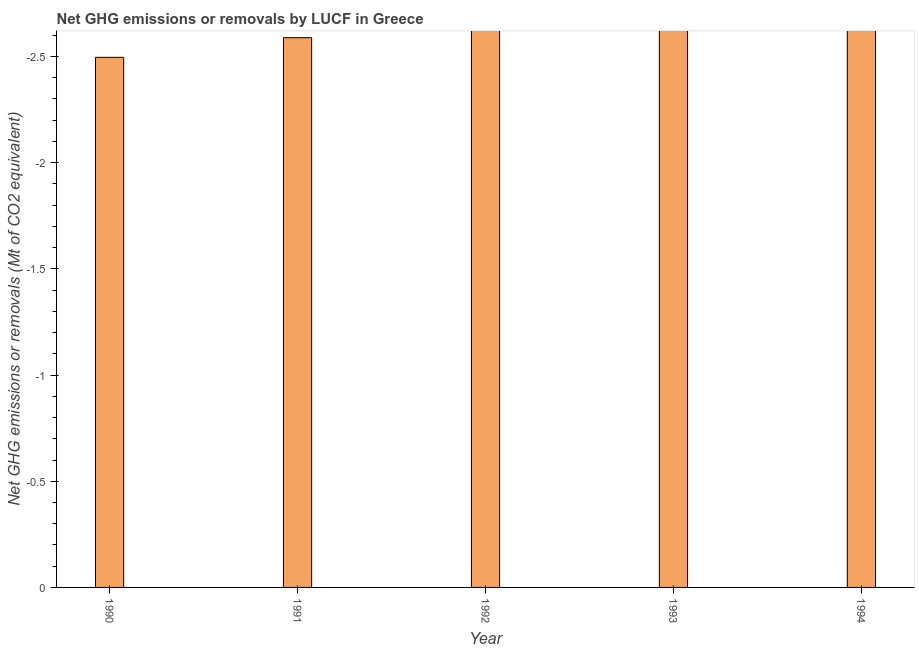What is the title of the graph?
Offer a very short reply. Net GHG emissions or removals by LUCF in Greece. What is the label or title of the Y-axis?
Ensure brevity in your answer.  Net GHG emissions or removals (Mt of CO2 equivalent). Across all years, what is the minimum ghg net emissions or removals?
Ensure brevity in your answer.  0. What is the sum of the ghg net emissions or removals?
Your answer should be very brief. 0. What is the median ghg net emissions or removals?
Provide a short and direct response. 0. In how many years, is the ghg net emissions or removals greater than the average ghg net emissions or removals taken over all years?
Your answer should be compact. 0. How many bars are there?
Offer a terse response. 0. How many years are there in the graph?
Offer a very short reply. 5. What is the Net GHG emissions or removals (Mt of CO2 equivalent) in 1990?
Offer a terse response. 0. What is the Net GHG emissions or removals (Mt of CO2 equivalent) in 1991?
Make the answer very short. 0. What is the Net GHG emissions or removals (Mt of CO2 equivalent) of 1992?
Offer a very short reply. 0. What is the Net GHG emissions or removals (Mt of CO2 equivalent) in 1993?
Your response must be concise. 0. 